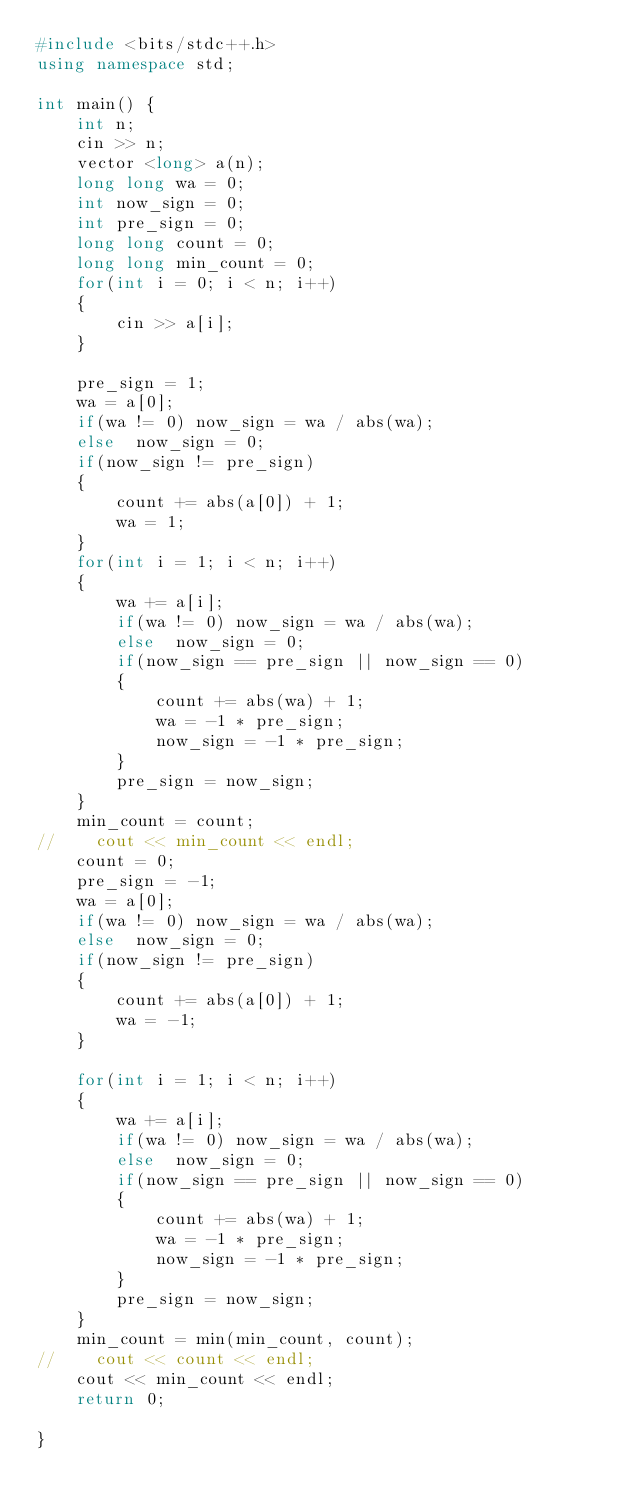<code> <loc_0><loc_0><loc_500><loc_500><_C++_>#include <bits/stdc++.h>
using namespace std;

int main() {
    int n;
    cin >> n;
    vector <long> a(n);
    long long wa = 0;
    int now_sign = 0;
    int pre_sign = 0;
    long long count = 0;
    long long min_count = 0;
    for(int i = 0; i < n; i++)
    {
        cin >> a[i];
    }

    pre_sign = 1;
    wa = a[0];
    if(wa != 0) now_sign = wa / abs(wa);
    else  now_sign = 0;
    if(now_sign != pre_sign)
    {
        count += abs(a[0]) + 1;
        wa = 1;
    }
    for(int i = 1; i < n; i++)
    {
        wa += a[i];
        if(wa != 0) now_sign = wa / abs(wa);
        else  now_sign = 0;
        if(now_sign == pre_sign || now_sign == 0)
        {
            count += abs(wa) + 1;
            wa = -1 * pre_sign;
            now_sign = -1 * pre_sign;
        }
        pre_sign = now_sign;
    }
    min_count = count;
//    cout << min_count << endl;
    count = 0;
    pre_sign = -1;
    wa = a[0];
    if(wa != 0) now_sign = wa / abs(wa);
    else  now_sign = 0;
    if(now_sign != pre_sign)
    {
        count += abs(a[0]) + 1;
        wa = -1;
    }

    for(int i = 1; i < n; i++)
    {
        wa += a[i];
        if(wa != 0) now_sign = wa / abs(wa);
        else  now_sign = 0;
        if(now_sign == pre_sign || now_sign == 0)
        {
            count += abs(wa) + 1;
            wa = -1 * pre_sign;
            now_sign = -1 * pre_sign;
        }
        pre_sign = now_sign;
    }
    min_count = min(min_count, count);
//    cout << count << endl;
    cout << min_count << endl;
    return 0;  

}</code> 